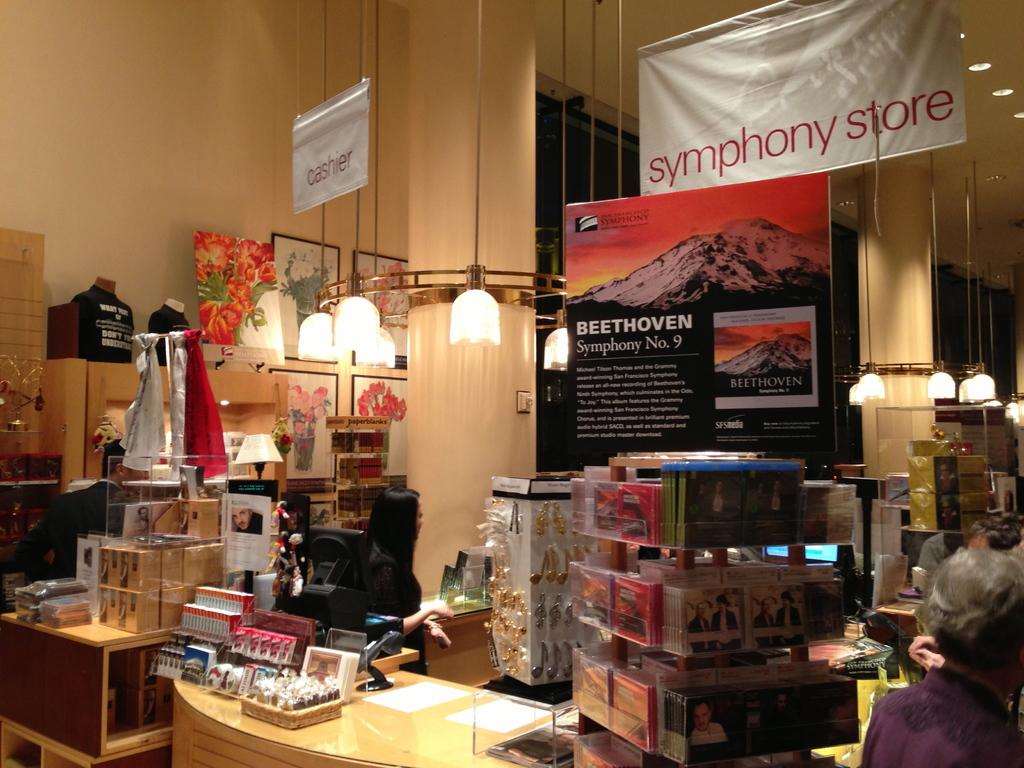<image>
Share a concise interpretation of the image provided. A symphony store sells Beethoven's Symphony # 9. 